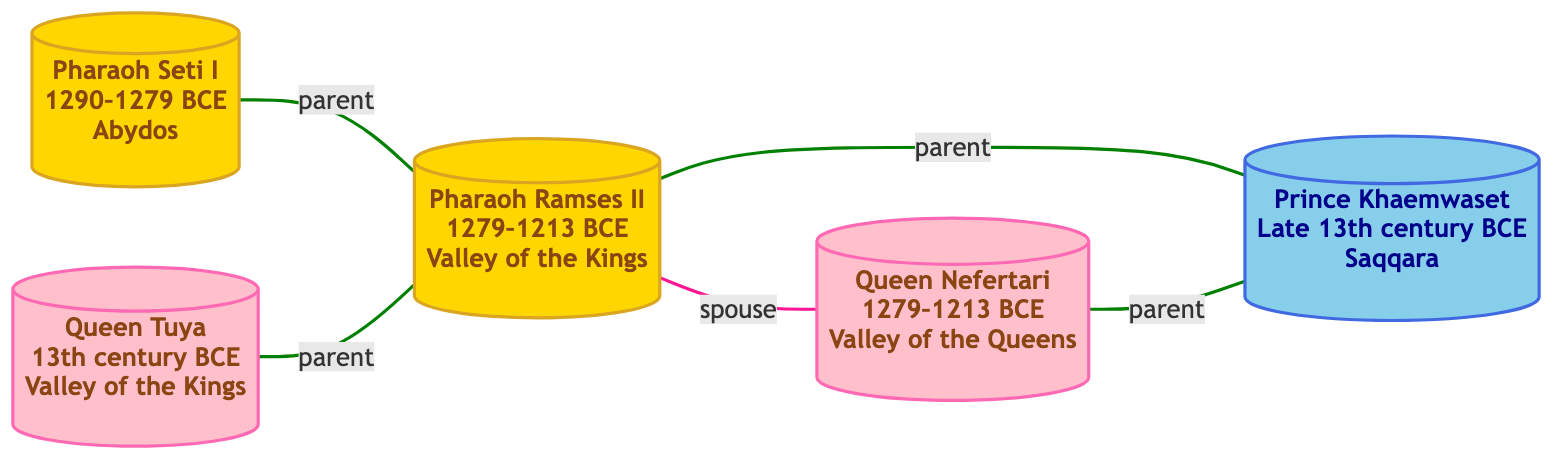What is the title of Pharaoh Ramses II? The title listed for Pharaoh Ramses II in the diagram is "Pharaoh of the Nineteenth Dynasty," which can be found directly next to his name.
Answer: Pharaoh of the Nineteenth Dynasty How many nodes are there in the diagram? By counting the individual nodes labeled with unique IDs in the diagram, we find that there are five nodes representing different royal figures.
Answer: 5 Who is the "Great Royal Wife" of Ramses II? In the diagram, the relationship is explicitly defined as "spouse" between Pharaoh Ramses II and Queen Nefertari, who holds the title of "Great Royal Wife of Ramses II."
Answer: Queen Nefertari What is the relationship between Pharaoh Seti I and Ramses II? The diagram shows a "parent" link from Pharaoh Seti I to Ramses II, indicating that Seti I is Ramses II's father.
Answer: parent Who discovered the tomb of Queen Tuya? The diagram does not provide specific information about who discovered Queen Tuya's tomb, as it focuses on relationships rather than discovery details. Thus, the answer remains unknown.
Answer: unknown How many parents does Prince Khaemwaset have? The diagram indicates that both Pharaoh Ramses II and Queen Nefertari are linked to Prince Khaemwaset as "parent," meaning he has two parents in total.
Answer: 2 What is the common discovery location for Ramses II and Queen Tuya? Both Pharaoh Ramses II and Queen Tuya have their discovery locations mentioned as "Valley of the Kings," making it their common location.
Answer: Valley of the Kings What is the title of Prince Khaemwaset? The title of Prince Khaemwaset, as noted in the diagram, is "High Priest of Ptah," presented directly next to his name.
Answer: High Priest of Ptah 